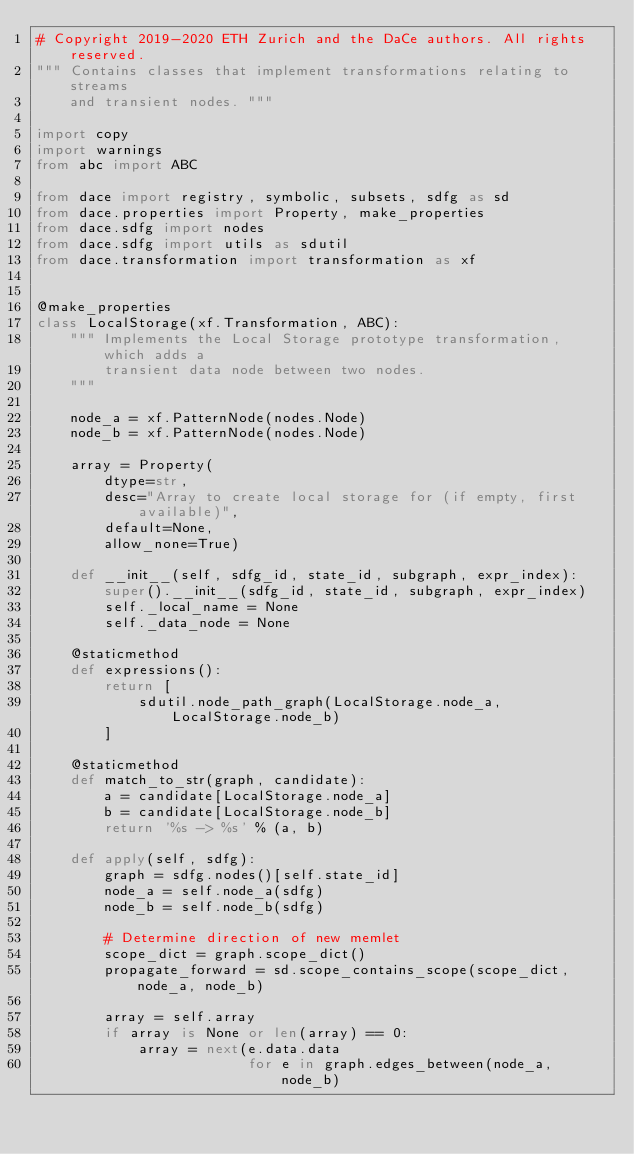<code> <loc_0><loc_0><loc_500><loc_500><_Python_># Copyright 2019-2020 ETH Zurich and the DaCe authors. All rights reserved.
""" Contains classes that implement transformations relating to streams
    and transient nodes. """

import copy
import warnings
from abc import ABC

from dace import registry, symbolic, subsets, sdfg as sd
from dace.properties import Property, make_properties
from dace.sdfg import nodes
from dace.sdfg import utils as sdutil
from dace.transformation import transformation as xf


@make_properties
class LocalStorage(xf.Transformation, ABC):
    """ Implements the Local Storage prototype transformation, which adds a
        transient data node between two nodes.
    """

    node_a = xf.PatternNode(nodes.Node)
    node_b = xf.PatternNode(nodes.Node)

    array = Property(
        dtype=str,
        desc="Array to create local storage for (if empty, first available)",
        default=None,
        allow_none=True)

    def __init__(self, sdfg_id, state_id, subgraph, expr_index):
        super().__init__(sdfg_id, state_id, subgraph, expr_index)
        self._local_name = None
        self._data_node = None

    @staticmethod
    def expressions():
        return [
            sdutil.node_path_graph(LocalStorage.node_a, LocalStorage.node_b)
        ]

    @staticmethod
    def match_to_str(graph, candidate):
        a = candidate[LocalStorage.node_a]
        b = candidate[LocalStorage.node_b]
        return '%s -> %s' % (a, b)

    def apply(self, sdfg):
        graph = sdfg.nodes()[self.state_id]
        node_a = self.node_a(sdfg)
        node_b = self.node_b(sdfg)

        # Determine direction of new memlet
        scope_dict = graph.scope_dict()
        propagate_forward = sd.scope_contains_scope(scope_dict, node_a, node_b)

        array = self.array
        if array is None or len(array) == 0:
            array = next(e.data.data
                         for e in graph.edges_between(node_a, node_b)</code> 